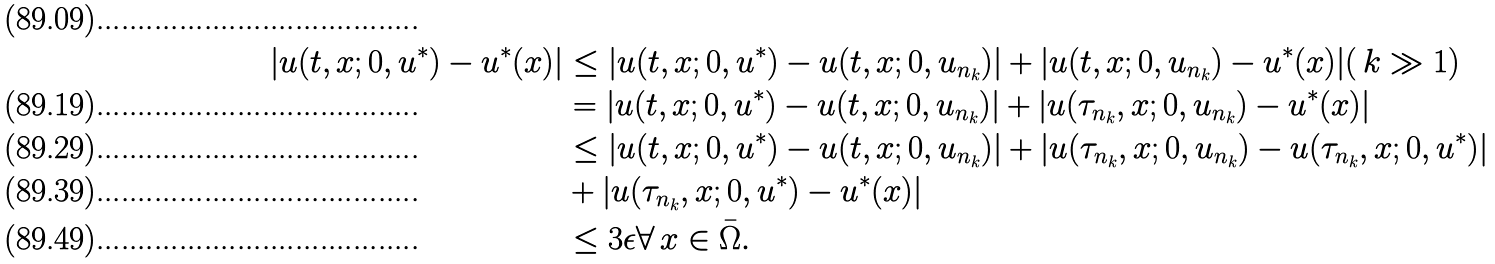<formula> <loc_0><loc_0><loc_500><loc_500>| u ( t , x ; 0 , u ^ { * } ) - u ^ { * } ( x ) | & \leq | u ( t , x ; 0 , u ^ { * } ) - u ( t , x ; 0 , u _ { n _ { k } } ) | + | u ( t , x ; 0 , u _ { n _ { k } } ) - u ^ { * } ( x ) | ( \, k \gg 1 ) \\ & = | u ( t , x ; 0 , u ^ { * } ) - u ( t , x ; 0 , u _ { n _ { k } } ) | + | u ( \tau _ { n _ { k } } , x ; 0 , u _ { n _ { k } } ) - u ^ { * } ( x ) | \\ & \leq | u ( t , x ; 0 , u ^ { * } ) - u ( t , x ; 0 , u _ { n _ { k } } ) | + | u ( \tau _ { n _ { k } } , x ; 0 , u _ { n _ { k } } ) - u ( \tau _ { n _ { k } } , x ; 0 , u ^ { * } ) | \\ & + | u ( \tau _ { n _ { k } } , x ; 0 , u ^ { * } ) - u ^ { * } ( x ) | \\ & \leq 3 \epsilon \forall \, x \in \bar { \Omega } .</formula> 